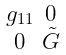<formula> <loc_0><loc_0><loc_500><loc_500>\begin{smallmatrix} g _ { 1 1 } & 0 \\ 0 & \tilde { G } \end{smallmatrix}</formula> 